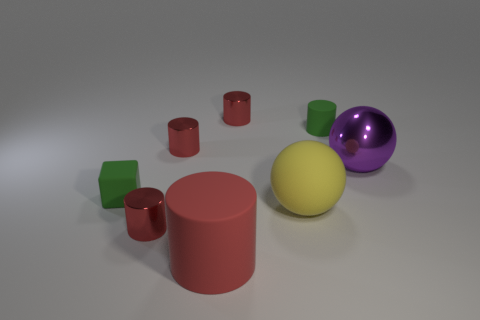What number of spheres are either tiny matte objects or red shiny objects?
Offer a terse response. 0. What is the size of the red object that is the same material as the small green cylinder?
Ensure brevity in your answer.  Large. There is a red shiny object that is in front of the tiny green rubber block; is it the same size as the matte cylinder left of the tiny green cylinder?
Offer a very short reply. No. What number of objects are either big red matte objects or small green metallic things?
Your answer should be very brief. 1. There is a big red object; what shape is it?
Your response must be concise. Cylinder. What size is the yellow rubber thing that is the same shape as the purple shiny object?
Offer a very short reply. Large. There is a red cylinder in front of the small thing that is in front of the tiny cube; how big is it?
Give a very brief answer. Large. Are there an equal number of red objects in front of the big yellow rubber ball and big yellow blocks?
Your response must be concise. No. What number of other objects are the same color as the big metal object?
Your answer should be compact. 0. Are there fewer tiny green matte cylinders that are left of the big purple object than cylinders?
Make the answer very short. Yes. 